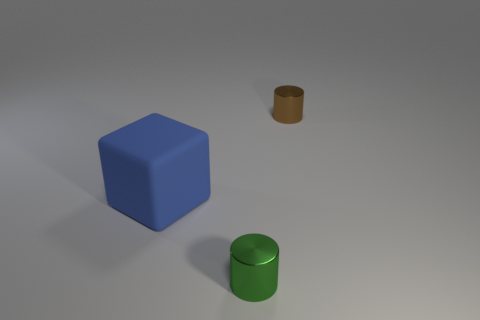Add 3 tiny green shiny balls. How many objects exist? 6 Subtract all cylinders. How many objects are left? 1 Subtract all purple shiny blocks. Subtract all blue rubber objects. How many objects are left? 2 Add 1 green cylinders. How many green cylinders are left? 2 Add 3 blue blocks. How many blue blocks exist? 4 Subtract 0 purple cylinders. How many objects are left? 3 